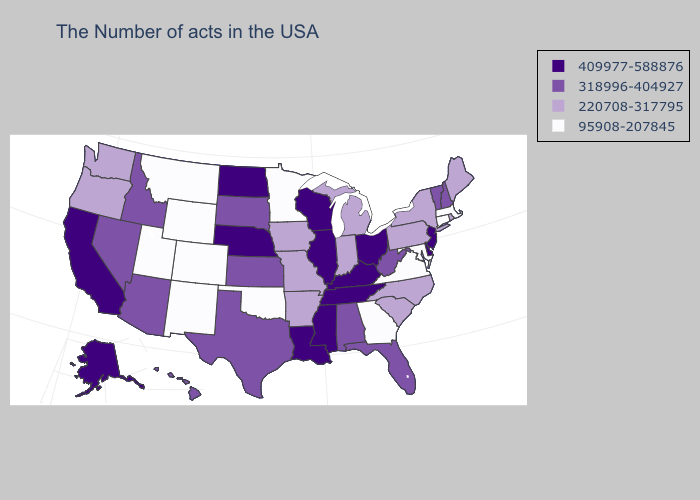What is the value of New Hampshire?
Give a very brief answer. 318996-404927. Does the map have missing data?
Quick response, please. No. Does the map have missing data?
Give a very brief answer. No. Does Wisconsin have the highest value in the USA?
Give a very brief answer. Yes. Name the states that have a value in the range 95908-207845?
Give a very brief answer. Massachusetts, Connecticut, Maryland, Virginia, Georgia, Minnesota, Oklahoma, Wyoming, Colorado, New Mexico, Utah, Montana. Among the states that border Wisconsin , which have the highest value?
Give a very brief answer. Illinois. What is the value of New Hampshire?
Quick response, please. 318996-404927. What is the lowest value in states that border Wyoming?
Keep it brief. 95908-207845. Among the states that border South Dakota , does Nebraska have the lowest value?
Short answer required. No. Name the states that have a value in the range 220708-317795?
Write a very short answer. Maine, Rhode Island, New York, Pennsylvania, North Carolina, South Carolina, Michigan, Indiana, Missouri, Arkansas, Iowa, Washington, Oregon. What is the lowest value in the USA?
Answer briefly. 95908-207845. Does the first symbol in the legend represent the smallest category?
Be succinct. No. Does the map have missing data?
Short answer required. No. Does North Dakota have the highest value in the MidWest?
Be succinct. Yes. Name the states that have a value in the range 409977-588876?
Keep it brief. New Jersey, Delaware, Ohio, Kentucky, Tennessee, Wisconsin, Illinois, Mississippi, Louisiana, Nebraska, North Dakota, California, Alaska. 